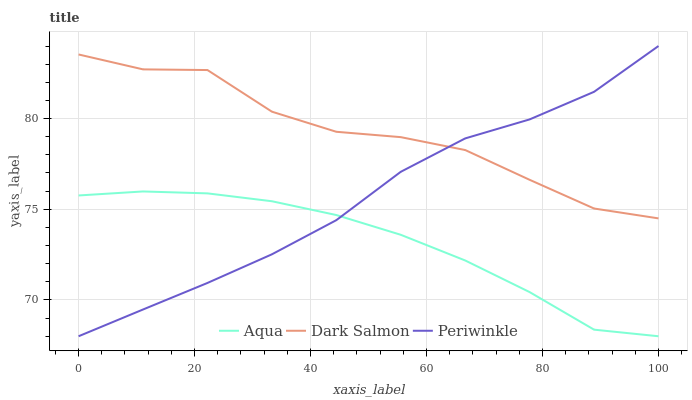Does Dark Salmon have the minimum area under the curve?
Answer yes or no. No. Does Aqua have the maximum area under the curve?
Answer yes or no. No. Is Dark Salmon the smoothest?
Answer yes or no. No. Is Aqua the roughest?
Answer yes or no. No. Does Dark Salmon have the lowest value?
Answer yes or no. No. Does Dark Salmon have the highest value?
Answer yes or no. No. Is Aqua less than Dark Salmon?
Answer yes or no. Yes. Is Dark Salmon greater than Aqua?
Answer yes or no. Yes. Does Aqua intersect Dark Salmon?
Answer yes or no. No. 